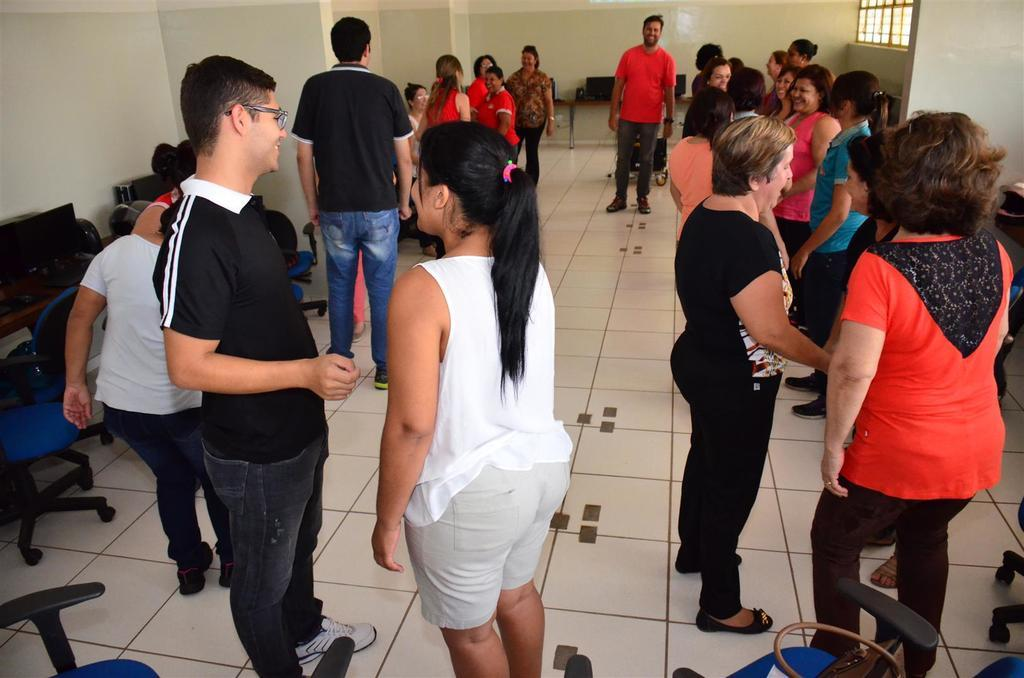What is happening in the room in the image? There are people standing in the room. What furniture is present in the room? There are tables and chairs in the room. What type of equipment can be seen in the room? There are systems (possibly computers or electronic devices) in the room. What architectural features are visible in the room? There is a window and a wall in the room. Can you see a bear wearing a mitten in the room? No, there is no bear or mitten present in the image. Are there any trains visible in the room? No, there are no trains present in the image. 